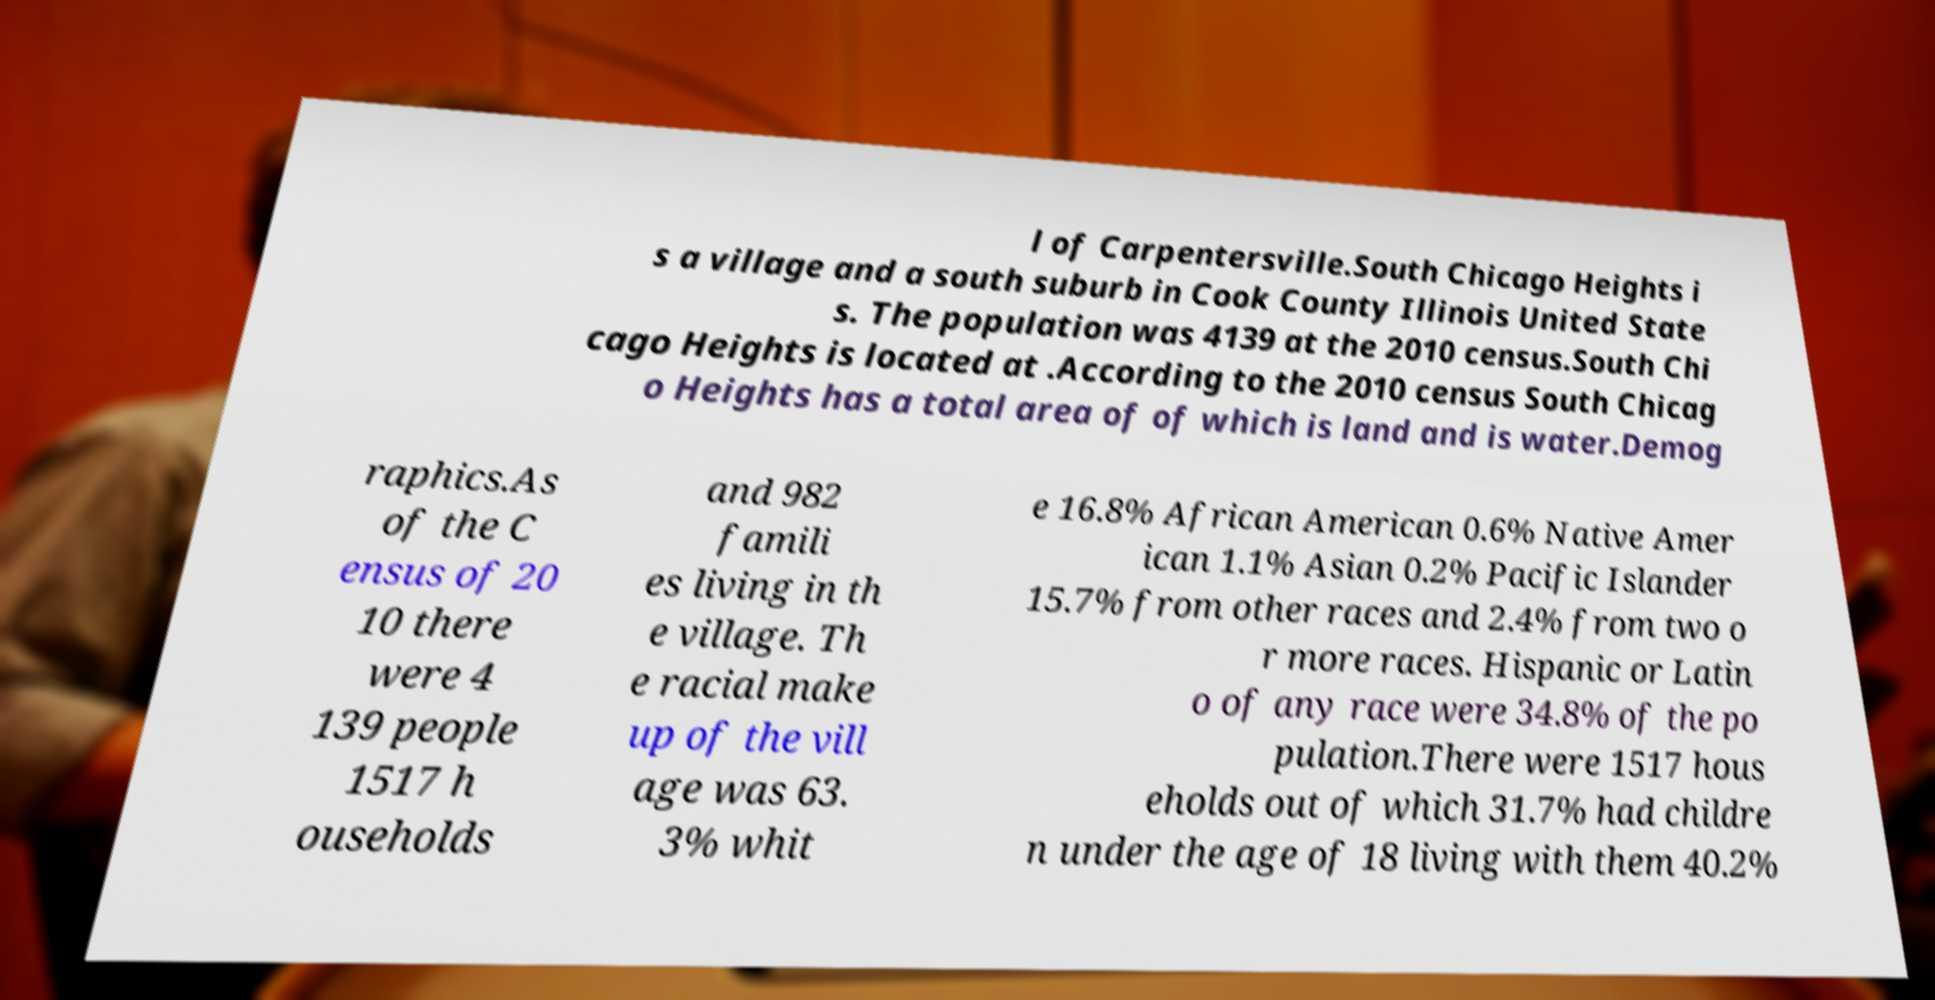For documentation purposes, I need the text within this image transcribed. Could you provide that? l of Carpentersville.South Chicago Heights i s a village and a south suburb in Cook County Illinois United State s. The population was 4139 at the 2010 census.South Chi cago Heights is located at .According to the 2010 census South Chicag o Heights has a total area of of which is land and is water.Demog raphics.As of the C ensus of 20 10 there were 4 139 people 1517 h ouseholds and 982 famili es living in th e village. Th e racial make up of the vill age was 63. 3% whit e 16.8% African American 0.6% Native Amer ican 1.1% Asian 0.2% Pacific Islander 15.7% from other races and 2.4% from two o r more races. Hispanic or Latin o of any race were 34.8% of the po pulation.There were 1517 hous eholds out of which 31.7% had childre n under the age of 18 living with them 40.2% 